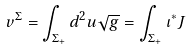<formula> <loc_0><loc_0><loc_500><loc_500>v ^ { \Sigma } = \int _ { \Sigma _ { + } } d ^ { 2 } u \sqrt { g } = \int _ { \Sigma _ { + } } \iota ^ { \ast } J</formula> 